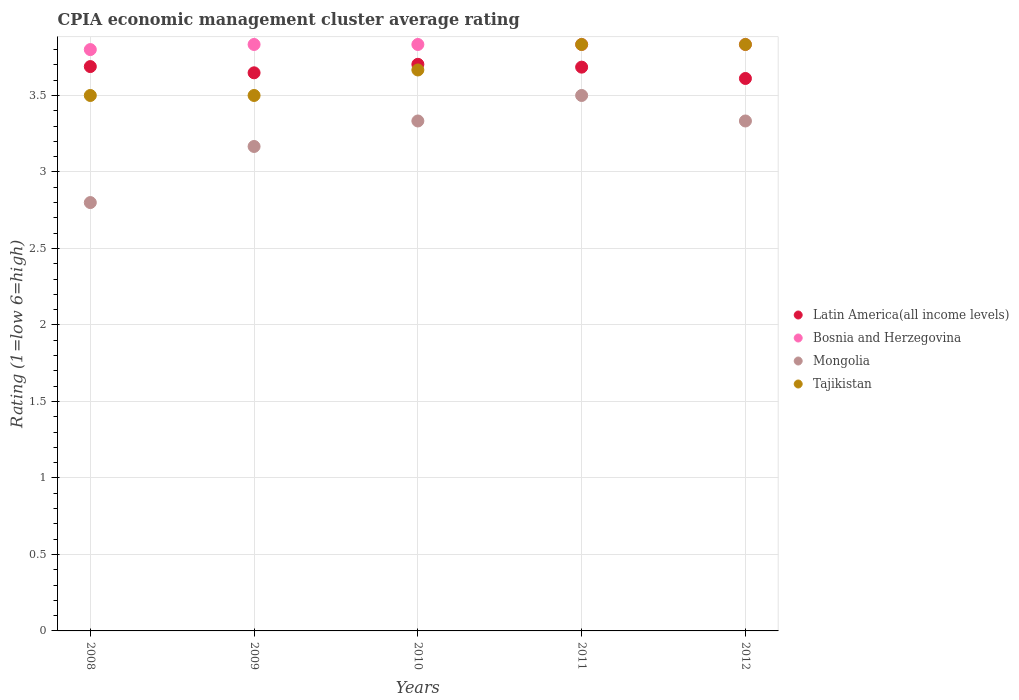How many different coloured dotlines are there?
Ensure brevity in your answer.  4. Is the number of dotlines equal to the number of legend labels?
Make the answer very short. Yes. What is the CPIA rating in Bosnia and Herzegovina in 2008?
Your answer should be very brief. 3.8. Across all years, what is the maximum CPIA rating in Bosnia and Herzegovina?
Offer a terse response. 3.83. Across all years, what is the minimum CPIA rating in Mongolia?
Provide a succinct answer. 2.8. In which year was the CPIA rating in Bosnia and Herzegovina maximum?
Your answer should be very brief. 2009. In which year was the CPIA rating in Mongolia minimum?
Offer a terse response. 2008. What is the total CPIA rating in Latin America(all income levels) in the graph?
Your response must be concise. 18.34. What is the difference between the CPIA rating in Latin America(all income levels) in 2010 and that in 2011?
Give a very brief answer. 0.02. What is the difference between the CPIA rating in Latin America(all income levels) in 2010 and the CPIA rating in Tajikistan in 2012?
Provide a succinct answer. -0.13. What is the average CPIA rating in Mongolia per year?
Give a very brief answer. 3.23. In the year 2012, what is the difference between the CPIA rating in Bosnia and Herzegovina and CPIA rating in Latin America(all income levels)?
Keep it short and to the point. 0.22. What is the ratio of the CPIA rating in Mongolia in 2009 to that in 2011?
Make the answer very short. 0.9. Is the CPIA rating in Mongolia in 2008 less than that in 2011?
Your answer should be very brief. Yes. Is the difference between the CPIA rating in Bosnia and Herzegovina in 2008 and 2012 greater than the difference between the CPIA rating in Latin America(all income levels) in 2008 and 2012?
Provide a succinct answer. No. What is the difference between the highest and the second highest CPIA rating in Tajikistan?
Offer a terse response. 0. What is the difference between the highest and the lowest CPIA rating in Latin America(all income levels)?
Ensure brevity in your answer.  0.09. Is it the case that in every year, the sum of the CPIA rating in Bosnia and Herzegovina and CPIA rating in Tajikistan  is greater than the sum of CPIA rating in Mongolia and CPIA rating in Latin America(all income levels)?
Offer a very short reply. No. Does the CPIA rating in Latin America(all income levels) monotonically increase over the years?
Keep it short and to the point. No. Is the CPIA rating in Tajikistan strictly less than the CPIA rating in Bosnia and Herzegovina over the years?
Make the answer very short. No. How many dotlines are there?
Make the answer very short. 4. Does the graph contain any zero values?
Provide a succinct answer. No. Does the graph contain grids?
Your answer should be compact. Yes. What is the title of the graph?
Offer a terse response. CPIA economic management cluster average rating. What is the label or title of the X-axis?
Make the answer very short. Years. What is the label or title of the Y-axis?
Provide a short and direct response. Rating (1=low 6=high). What is the Rating (1=low 6=high) in Latin America(all income levels) in 2008?
Provide a succinct answer. 3.69. What is the Rating (1=low 6=high) of Bosnia and Herzegovina in 2008?
Your response must be concise. 3.8. What is the Rating (1=low 6=high) of Mongolia in 2008?
Make the answer very short. 2.8. What is the Rating (1=low 6=high) of Tajikistan in 2008?
Make the answer very short. 3.5. What is the Rating (1=low 6=high) of Latin America(all income levels) in 2009?
Provide a short and direct response. 3.65. What is the Rating (1=low 6=high) of Bosnia and Herzegovina in 2009?
Your response must be concise. 3.83. What is the Rating (1=low 6=high) in Mongolia in 2009?
Offer a terse response. 3.17. What is the Rating (1=low 6=high) of Latin America(all income levels) in 2010?
Your answer should be very brief. 3.7. What is the Rating (1=low 6=high) in Bosnia and Herzegovina in 2010?
Provide a succinct answer. 3.83. What is the Rating (1=low 6=high) of Mongolia in 2010?
Provide a succinct answer. 3.33. What is the Rating (1=low 6=high) in Tajikistan in 2010?
Provide a succinct answer. 3.67. What is the Rating (1=low 6=high) of Latin America(all income levels) in 2011?
Give a very brief answer. 3.69. What is the Rating (1=low 6=high) of Bosnia and Herzegovina in 2011?
Offer a terse response. 3.83. What is the Rating (1=low 6=high) of Mongolia in 2011?
Offer a very short reply. 3.5. What is the Rating (1=low 6=high) in Tajikistan in 2011?
Offer a terse response. 3.83. What is the Rating (1=low 6=high) in Latin America(all income levels) in 2012?
Offer a very short reply. 3.61. What is the Rating (1=low 6=high) of Bosnia and Herzegovina in 2012?
Offer a very short reply. 3.83. What is the Rating (1=low 6=high) in Mongolia in 2012?
Your answer should be compact. 3.33. What is the Rating (1=low 6=high) in Tajikistan in 2012?
Offer a terse response. 3.83. Across all years, what is the maximum Rating (1=low 6=high) of Latin America(all income levels)?
Give a very brief answer. 3.7. Across all years, what is the maximum Rating (1=low 6=high) in Bosnia and Herzegovina?
Make the answer very short. 3.83. Across all years, what is the maximum Rating (1=low 6=high) in Mongolia?
Your answer should be compact. 3.5. Across all years, what is the maximum Rating (1=low 6=high) of Tajikistan?
Your response must be concise. 3.83. Across all years, what is the minimum Rating (1=low 6=high) in Latin America(all income levels)?
Ensure brevity in your answer.  3.61. Across all years, what is the minimum Rating (1=low 6=high) in Tajikistan?
Provide a succinct answer. 3.5. What is the total Rating (1=low 6=high) of Latin America(all income levels) in the graph?
Your answer should be very brief. 18.34. What is the total Rating (1=low 6=high) of Bosnia and Herzegovina in the graph?
Your response must be concise. 19.13. What is the total Rating (1=low 6=high) of Mongolia in the graph?
Keep it short and to the point. 16.13. What is the total Rating (1=low 6=high) in Tajikistan in the graph?
Provide a succinct answer. 18.33. What is the difference between the Rating (1=low 6=high) of Latin America(all income levels) in 2008 and that in 2009?
Your response must be concise. 0.04. What is the difference between the Rating (1=low 6=high) in Bosnia and Herzegovina in 2008 and that in 2009?
Make the answer very short. -0.03. What is the difference between the Rating (1=low 6=high) in Mongolia in 2008 and that in 2009?
Keep it short and to the point. -0.37. What is the difference between the Rating (1=low 6=high) of Tajikistan in 2008 and that in 2009?
Offer a very short reply. 0. What is the difference between the Rating (1=low 6=high) of Latin America(all income levels) in 2008 and that in 2010?
Make the answer very short. -0.01. What is the difference between the Rating (1=low 6=high) of Bosnia and Herzegovina in 2008 and that in 2010?
Provide a short and direct response. -0.03. What is the difference between the Rating (1=low 6=high) in Mongolia in 2008 and that in 2010?
Provide a short and direct response. -0.53. What is the difference between the Rating (1=low 6=high) in Tajikistan in 2008 and that in 2010?
Give a very brief answer. -0.17. What is the difference between the Rating (1=low 6=high) in Latin America(all income levels) in 2008 and that in 2011?
Provide a short and direct response. 0. What is the difference between the Rating (1=low 6=high) of Bosnia and Herzegovina in 2008 and that in 2011?
Make the answer very short. -0.03. What is the difference between the Rating (1=low 6=high) of Mongolia in 2008 and that in 2011?
Give a very brief answer. -0.7. What is the difference between the Rating (1=low 6=high) in Tajikistan in 2008 and that in 2011?
Your answer should be very brief. -0.33. What is the difference between the Rating (1=low 6=high) in Latin America(all income levels) in 2008 and that in 2012?
Provide a short and direct response. 0.08. What is the difference between the Rating (1=low 6=high) of Bosnia and Herzegovina in 2008 and that in 2012?
Offer a terse response. -0.03. What is the difference between the Rating (1=low 6=high) of Mongolia in 2008 and that in 2012?
Your answer should be very brief. -0.53. What is the difference between the Rating (1=low 6=high) of Tajikistan in 2008 and that in 2012?
Keep it short and to the point. -0.33. What is the difference between the Rating (1=low 6=high) of Latin America(all income levels) in 2009 and that in 2010?
Your answer should be compact. -0.06. What is the difference between the Rating (1=low 6=high) of Bosnia and Herzegovina in 2009 and that in 2010?
Provide a succinct answer. 0. What is the difference between the Rating (1=low 6=high) of Latin America(all income levels) in 2009 and that in 2011?
Provide a short and direct response. -0.04. What is the difference between the Rating (1=low 6=high) in Tajikistan in 2009 and that in 2011?
Your answer should be very brief. -0.33. What is the difference between the Rating (1=low 6=high) in Latin America(all income levels) in 2009 and that in 2012?
Give a very brief answer. 0.04. What is the difference between the Rating (1=low 6=high) of Tajikistan in 2009 and that in 2012?
Give a very brief answer. -0.33. What is the difference between the Rating (1=low 6=high) in Latin America(all income levels) in 2010 and that in 2011?
Your answer should be compact. 0.02. What is the difference between the Rating (1=low 6=high) of Mongolia in 2010 and that in 2011?
Offer a terse response. -0.17. What is the difference between the Rating (1=low 6=high) of Tajikistan in 2010 and that in 2011?
Ensure brevity in your answer.  -0.17. What is the difference between the Rating (1=low 6=high) in Latin America(all income levels) in 2010 and that in 2012?
Provide a short and direct response. 0.09. What is the difference between the Rating (1=low 6=high) in Bosnia and Herzegovina in 2010 and that in 2012?
Keep it short and to the point. 0. What is the difference between the Rating (1=low 6=high) in Mongolia in 2010 and that in 2012?
Provide a succinct answer. 0. What is the difference between the Rating (1=low 6=high) in Latin America(all income levels) in 2011 and that in 2012?
Your answer should be very brief. 0.07. What is the difference between the Rating (1=low 6=high) of Bosnia and Herzegovina in 2011 and that in 2012?
Keep it short and to the point. 0. What is the difference between the Rating (1=low 6=high) of Mongolia in 2011 and that in 2012?
Provide a short and direct response. 0.17. What is the difference between the Rating (1=low 6=high) in Tajikistan in 2011 and that in 2012?
Your answer should be very brief. 0. What is the difference between the Rating (1=low 6=high) in Latin America(all income levels) in 2008 and the Rating (1=low 6=high) in Bosnia and Herzegovina in 2009?
Your answer should be compact. -0.14. What is the difference between the Rating (1=low 6=high) of Latin America(all income levels) in 2008 and the Rating (1=low 6=high) of Mongolia in 2009?
Your answer should be very brief. 0.52. What is the difference between the Rating (1=low 6=high) of Latin America(all income levels) in 2008 and the Rating (1=low 6=high) of Tajikistan in 2009?
Offer a terse response. 0.19. What is the difference between the Rating (1=low 6=high) in Bosnia and Herzegovina in 2008 and the Rating (1=low 6=high) in Mongolia in 2009?
Your response must be concise. 0.63. What is the difference between the Rating (1=low 6=high) of Bosnia and Herzegovina in 2008 and the Rating (1=low 6=high) of Tajikistan in 2009?
Keep it short and to the point. 0.3. What is the difference between the Rating (1=low 6=high) in Latin America(all income levels) in 2008 and the Rating (1=low 6=high) in Bosnia and Herzegovina in 2010?
Offer a terse response. -0.14. What is the difference between the Rating (1=low 6=high) of Latin America(all income levels) in 2008 and the Rating (1=low 6=high) of Mongolia in 2010?
Your answer should be very brief. 0.36. What is the difference between the Rating (1=low 6=high) in Latin America(all income levels) in 2008 and the Rating (1=low 6=high) in Tajikistan in 2010?
Your answer should be compact. 0.02. What is the difference between the Rating (1=low 6=high) of Bosnia and Herzegovina in 2008 and the Rating (1=low 6=high) of Mongolia in 2010?
Keep it short and to the point. 0.47. What is the difference between the Rating (1=low 6=high) in Bosnia and Herzegovina in 2008 and the Rating (1=low 6=high) in Tajikistan in 2010?
Make the answer very short. 0.13. What is the difference between the Rating (1=low 6=high) of Mongolia in 2008 and the Rating (1=low 6=high) of Tajikistan in 2010?
Give a very brief answer. -0.87. What is the difference between the Rating (1=low 6=high) of Latin America(all income levels) in 2008 and the Rating (1=low 6=high) of Bosnia and Herzegovina in 2011?
Your response must be concise. -0.14. What is the difference between the Rating (1=low 6=high) of Latin America(all income levels) in 2008 and the Rating (1=low 6=high) of Mongolia in 2011?
Offer a very short reply. 0.19. What is the difference between the Rating (1=low 6=high) in Latin America(all income levels) in 2008 and the Rating (1=low 6=high) in Tajikistan in 2011?
Give a very brief answer. -0.14. What is the difference between the Rating (1=low 6=high) of Bosnia and Herzegovina in 2008 and the Rating (1=low 6=high) of Mongolia in 2011?
Make the answer very short. 0.3. What is the difference between the Rating (1=low 6=high) in Bosnia and Herzegovina in 2008 and the Rating (1=low 6=high) in Tajikistan in 2011?
Your answer should be very brief. -0.03. What is the difference between the Rating (1=low 6=high) in Mongolia in 2008 and the Rating (1=low 6=high) in Tajikistan in 2011?
Make the answer very short. -1.03. What is the difference between the Rating (1=low 6=high) of Latin America(all income levels) in 2008 and the Rating (1=low 6=high) of Bosnia and Herzegovina in 2012?
Your answer should be very brief. -0.14. What is the difference between the Rating (1=low 6=high) in Latin America(all income levels) in 2008 and the Rating (1=low 6=high) in Mongolia in 2012?
Your answer should be compact. 0.36. What is the difference between the Rating (1=low 6=high) in Latin America(all income levels) in 2008 and the Rating (1=low 6=high) in Tajikistan in 2012?
Offer a very short reply. -0.14. What is the difference between the Rating (1=low 6=high) of Bosnia and Herzegovina in 2008 and the Rating (1=low 6=high) of Mongolia in 2012?
Your response must be concise. 0.47. What is the difference between the Rating (1=low 6=high) of Bosnia and Herzegovina in 2008 and the Rating (1=low 6=high) of Tajikistan in 2012?
Your answer should be compact. -0.03. What is the difference between the Rating (1=low 6=high) in Mongolia in 2008 and the Rating (1=low 6=high) in Tajikistan in 2012?
Ensure brevity in your answer.  -1.03. What is the difference between the Rating (1=low 6=high) in Latin America(all income levels) in 2009 and the Rating (1=low 6=high) in Bosnia and Herzegovina in 2010?
Ensure brevity in your answer.  -0.19. What is the difference between the Rating (1=low 6=high) in Latin America(all income levels) in 2009 and the Rating (1=low 6=high) in Mongolia in 2010?
Your answer should be compact. 0.31. What is the difference between the Rating (1=low 6=high) of Latin America(all income levels) in 2009 and the Rating (1=low 6=high) of Tajikistan in 2010?
Your response must be concise. -0.02. What is the difference between the Rating (1=low 6=high) in Bosnia and Herzegovina in 2009 and the Rating (1=low 6=high) in Mongolia in 2010?
Ensure brevity in your answer.  0.5. What is the difference between the Rating (1=low 6=high) in Bosnia and Herzegovina in 2009 and the Rating (1=low 6=high) in Tajikistan in 2010?
Make the answer very short. 0.17. What is the difference between the Rating (1=low 6=high) of Mongolia in 2009 and the Rating (1=low 6=high) of Tajikistan in 2010?
Offer a very short reply. -0.5. What is the difference between the Rating (1=low 6=high) of Latin America(all income levels) in 2009 and the Rating (1=low 6=high) of Bosnia and Herzegovina in 2011?
Provide a short and direct response. -0.19. What is the difference between the Rating (1=low 6=high) of Latin America(all income levels) in 2009 and the Rating (1=low 6=high) of Mongolia in 2011?
Offer a very short reply. 0.15. What is the difference between the Rating (1=low 6=high) of Latin America(all income levels) in 2009 and the Rating (1=low 6=high) of Tajikistan in 2011?
Provide a succinct answer. -0.19. What is the difference between the Rating (1=low 6=high) in Bosnia and Herzegovina in 2009 and the Rating (1=low 6=high) in Mongolia in 2011?
Ensure brevity in your answer.  0.33. What is the difference between the Rating (1=low 6=high) of Bosnia and Herzegovina in 2009 and the Rating (1=low 6=high) of Tajikistan in 2011?
Offer a very short reply. 0. What is the difference between the Rating (1=low 6=high) of Latin America(all income levels) in 2009 and the Rating (1=low 6=high) of Bosnia and Herzegovina in 2012?
Give a very brief answer. -0.19. What is the difference between the Rating (1=low 6=high) of Latin America(all income levels) in 2009 and the Rating (1=low 6=high) of Mongolia in 2012?
Make the answer very short. 0.31. What is the difference between the Rating (1=low 6=high) in Latin America(all income levels) in 2009 and the Rating (1=low 6=high) in Tajikistan in 2012?
Provide a short and direct response. -0.19. What is the difference between the Rating (1=low 6=high) of Mongolia in 2009 and the Rating (1=low 6=high) of Tajikistan in 2012?
Your answer should be compact. -0.67. What is the difference between the Rating (1=low 6=high) in Latin America(all income levels) in 2010 and the Rating (1=low 6=high) in Bosnia and Herzegovina in 2011?
Your answer should be very brief. -0.13. What is the difference between the Rating (1=low 6=high) of Latin America(all income levels) in 2010 and the Rating (1=low 6=high) of Mongolia in 2011?
Your answer should be very brief. 0.2. What is the difference between the Rating (1=low 6=high) in Latin America(all income levels) in 2010 and the Rating (1=low 6=high) in Tajikistan in 2011?
Ensure brevity in your answer.  -0.13. What is the difference between the Rating (1=low 6=high) of Latin America(all income levels) in 2010 and the Rating (1=low 6=high) of Bosnia and Herzegovina in 2012?
Ensure brevity in your answer.  -0.13. What is the difference between the Rating (1=low 6=high) in Latin America(all income levels) in 2010 and the Rating (1=low 6=high) in Mongolia in 2012?
Your answer should be very brief. 0.37. What is the difference between the Rating (1=low 6=high) in Latin America(all income levels) in 2010 and the Rating (1=low 6=high) in Tajikistan in 2012?
Provide a succinct answer. -0.13. What is the difference between the Rating (1=low 6=high) of Latin America(all income levels) in 2011 and the Rating (1=low 6=high) of Bosnia and Herzegovina in 2012?
Offer a terse response. -0.15. What is the difference between the Rating (1=low 6=high) of Latin America(all income levels) in 2011 and the Rating (1=low 6=high) of Mongolia in 2012?
Your answer should be compact. 0.35. What is the difference between the Rating (1=low 6=high) in Latin America(all income levels) in 2011 and the Rating (1=low 6=high) in Tajikistan in 2012?
Your response must be concise. -0.15. What is the difference between the Rating (1=low 6=high) of Bosnia and Herzegovina in 2011 and the Rating (1=low 6=high) of Mongolia in 2012?
Provide a succinct answer. 0.5. What is the difference between the Rating (1=low 6=high) of Bosnia and Herzegovina in 2011 and the Rating (1=low 6=high) of Tajikistan in 2012?
Your answer should be compact. 0. What is the difference between the Rating (1=low 6=high) of Mongolia in 2011 and the Rating (1=low 6=high) of Tajikistan in 2012?
Offer a terse response. -0.33. What is the average Rating (1=low 6=high) of Latin America(all income levels) per year?
Your answer should be very brief. 3.67. What is the average Rating (1=low 6=high) of Bosnia and Herzegovina per year?
Your answer should be very brief. 3.83. What is the average Rating (1=low 6=high) of Mongolia per year?
Offer a terse response. 3.23. What is the average Rating (1=low 6=high) in Tajikistan per year?
Ensure brevity in your answer.  3.67. In the year 2008, what is the difference between the Rating (1=low 6=high) in Latin America(all income levels) and Rating (1=low 6=high) in Bosnia and Herzegovina?
Ensure brevity in your answer.  -0.11. In the year 2008, what is the difference between the Rating (1=low 6=high) of Latin America(all income levels) and Rating (1=low 6=high) of Tajikistan?
Offer a terse response. 0.19. In the year 2008, what is the difference between the Rating (1=low 6=high) of Bosnia and Herzegovina and Rating (1=low 6=high) of Mongolia?
Ensure brevity in your answer.  1. In the year 2008, what is the difference between the Rating (1=low 6=high) of Bosnia and Herzegovina and Rating (1=low 6=high) of Tajikistan?
Offer a terse response. 0.3. In the year 2008, what is the difference between the Rating (1=low 6=high) in Mongolia and Rating (1=low 6=high) in Tajikistan?
Your answer should be very brief. -0.7. In the year 2009, what is the difference between the Rating (1=low 6=high) in Latin America(all income levels) and Rating (1=low 6=high) in Bosnia and Herzegovina?
Keep it short and to the point. -0.19. In the year 2009, what is the difference between the Rating (1=low 6=high) of Latin America(all income levels) and Rating (1=low 6=high) of Mongolia?
Offer a very short reply. 0.48. In the year 2009, what is the difference between the Rating (1=low 6=high) in Latin America(all income levels) and Rating (1=low 6=high) in Tajikistan?
Offer a very short reply. 0.15. In the year 2009, what is the difference between the Rating (1=low 6=high) of Bosnia and Herzegovina and Rating (1=low 6=high) of Mongolia?
Make the answer very short. 0.67. In the year 2009, what is the difference between the Rating (1=low 6=high) in Bosnia and Herzegovina and Rating (1=low 6=high) in Tajikistan?
Provide a succinct answer. 0.33. In the year 2009, what is the difference between the Rating (1=low 6=high) of Mongolia and Rating (1=low 6=high) of Tajikistan?
Keep it short and to the point. -0.33. In the year 2010, what is the difference between the Rating (1=low 6=high) of Latin America(all income levels) and Rating (1=low 6=high) of Bosnia and Herzegovina?
Your answer should be compact. -0.13. In the year 2010, what is the difference between the Rating (1=low 6=high) of Latin America(all income levels) and Rating (1=low 6=high) of Mongolia?
Provide a short and direct response. 0.37. In the year 2010, what is the difference between the Rating (1=low 6=high) in Latin America(all income levels) and Rating (1=low 6=high) in Tajikistan?
Provide a succinct answer. 0.04. In the year 2011, what is the difference between the Rating (1=low 6=high) in Latin America(all income levels) and Rating (1=low 6=high) in Bosnia and Herzegovina?
Keep it short and to the point. -0.15. In the year 2011, what is the difference between the Rating (1=low 6=high) of Latin America(all income levels) and Rating (1=low 6=high) of Mongolia?
Make the answer very short. 0.19. In the year 2011, what is the difference between the Rating (1=low 6=high) in Latin America(all income levels) and Rating (1=low 6=high) in Tajikistan?
Give a very brief answer. -0.15. In the year 2011, what is the difference between the Rating (1=low 6=high) of Bosnia and Herzegovina and Rating (1=low 6=high) of Tajikistan?
Provide a short and direct response. 0. In the year 2011, what is the difference between the Rating (1=low 6=high) in Mongolia and Rating (1=low 6=high) in Tajikistan?
Ensure brevity in your answer.  -0.33. In the year 2012, what is the difference between the Rating (1=low 6=high) of Latin America(all income levels) and Rating (1=low 6=high) of Bosnia and Herzegovina?
Offer a terse response. -0.22. In the year 2012, what is the difference between the Rating (1=low 6=high) in Latin America(all income levels) and Rating (1=low 6=high) in Mongolia?
Provide a succinct answer. 0.28. In the year 2012, what is the difference between the Rating (1=low 6=high) of Latin America(all income levels) and Rating (1=low 6=high) of Tajikistan?
Ensure brevity in your answer.  -0.22. In the year 2012, what is the difference between the Rating (1=low 6=high) of Bosnia and Herzegovina and Rating (1=low 6=high) of Mongolia?
Ensure brevity in your answer.  0.5. In the year 2012, what is the difference between the Rating (1=low 6=high) in Bosnia and Herzegovina and Rating (1=low 6=high) in Tajikistan?
Make the answer very short. 0. What is the ratio of the Rating (1=low 6=high) in Latin America(all income levels) in 2008 to that in 2009?
Provide a succinct answer. 1.01. What is the ratio of the Rating (1=low 6=high) of Mongolia in 2008 to that in 2009?
Offer a very short reply. 0.88. What is the ratio of the Rating (1=low 6=high) in Latin America(all income levels) in 2008 to that in 2010?
Offer a terse response. 1. What is the ratio of the Rating (1=low 6=high) of Bosnia and Herzegovina in 2008 to that in 2010?
Your answer should be compact. 0.99. What is the ratio of the Rating (1=low 6=high) in Mongolia in 2008 to that in 2010?
Keep it short and to the point. 0.84. What is the ratio of the Rating (1=low 6=high) in Tajikistan in 2008 to that in 2010?
Give a very brief answer. 0.95. What is the ratio of the Rating (1=low 6=high) in Bosnia and Herzegovina in 2008 to that in 2011?
Offer a terse response. 0.99. What is the ratio of the Rating (1=low 6=high) in Mongolia in 2008 to that in 2011?
Keep it short and to the point. 0.8. What is the ratio of the Rating (1=low 6=high) in Latin America(all income levels) in 2008 to that in 2012?
Provide a succinct answer. 1.02. What is the ratio of the Rating (1=low 6=high) in Bosnia and Herzegovina in 2008 to that in 2012?
Ensure brevity in your answer.  0.99. What is the ratio of the Rating (1=low 6=high) of Mongolia in 2008 to that in 2012?
Give a very brief answer. 0.84. What is the ratio of the Rating (1=low 6=high) in Tajikistan in 2008 to that in 2012?
Ensure brevity in your answer.  0.91. What is the ratio of the Rating (1=low 6=high) in Tajikistan in 2009 to that in 2010?
Your answer should be compact. 0.95. What is the ratio of the Rating (1=low 6=high) in Bosnia and Herzegovina in 2009 to that in 2011?
Give a very brief answer. 1. What is the ratio of the Rating (1=low 6=high) of Mongolia in 2009 to that in 2011?
Ensure brevity in your answer.  0.9. What is the ratio of the Rating (1=low 6=high) in Latin America(all income levels) in 2009 to that in 2012?
Provide a succinct answer. 1.01. What is the ratio of the Rating (1=low 6=high) in Mongolia in 2009 to that in 2012?
Give a very brief answer. 0.95. What is the ratio of the Rating (1=low 6=high) in Tajikistan in 2009 to that in 2012?
Your answer should be compact. 0.91. What is the ratio of the Rating (1=low 6=high) of Latin America(all income levels) in 2010 to that in 2011?
Your response must be concise. 1. What is the ratio of the Rating (1=low 6=high) in Bosnia and Herzegovina in 2010 to that in 2011?
Make the answer very short. 1. What is the ratio of the Rating (1=low 6=high) in Tajikistan in 2010 to that in 2011?
Keep it short and to the point. 0.96. What is the ratio of the Rating (1=low 6=high) in Latin America(all income levels) in 2010 to that in 2012?
Offer a very short reply. 1.03. What is the ratio of the Rating (1=low 6=high) of Bosnia and Herzegovina in 2010 to that in 2012?
Ensure brevity in your answer.  1. What is the ratio of the Rating (1=low 6=high) of Tajikistan in 2010 to that in 2012?
Keep it short and to the point. 0.96. What is the ratio of the Rating (1=low 6=high) of Latin America(all income levels) in 2011 to that in 2012?
Give a very brief answer. 1.02. What is the ratio of the Rating (1=low 6=high) in Mongolia in 2011 to that in 2012?
Ensure brevity in your answer.  1.05. What is the difference between the highest and the second highest Rating (1=low 6=high) in Latin America(all income levels)?
Offer a terse response. 0.01. What is the difference between the highest and the second highest Rating (1=low 6=high) in Tajikistan?
Your answer should be very brief. 0. What is the difference between the highest and the lowest Rating (1=low 6=high) in Latin America(all income levels)?
Your answer should be very brief. 0.09. What is the difference between the highest and the lowest Rating (1=low 6=high) in Bosnia and Herzegovina?
Provide a short and direct response. 0.03. 